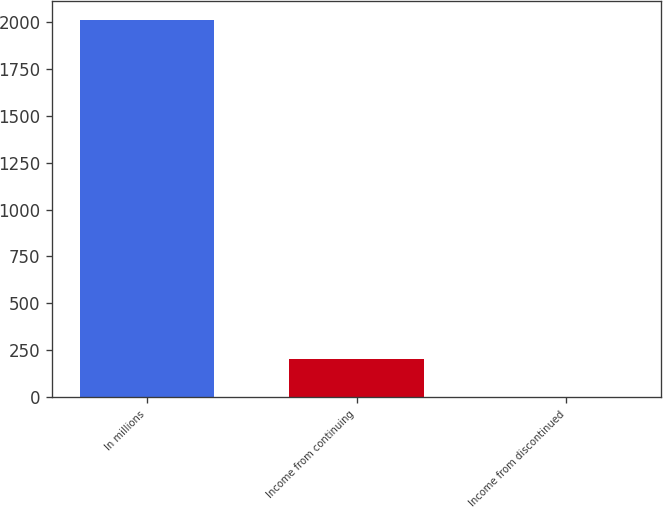Convert chart. <chart><loc_0><loc_0><loc_500><loc_500><bar_chart><fcel>In millions<fcel>Income from continuing<fcel>Income from discontinued<nl><fcel>2012<fcel>203<fcel>2<nl></chart> 